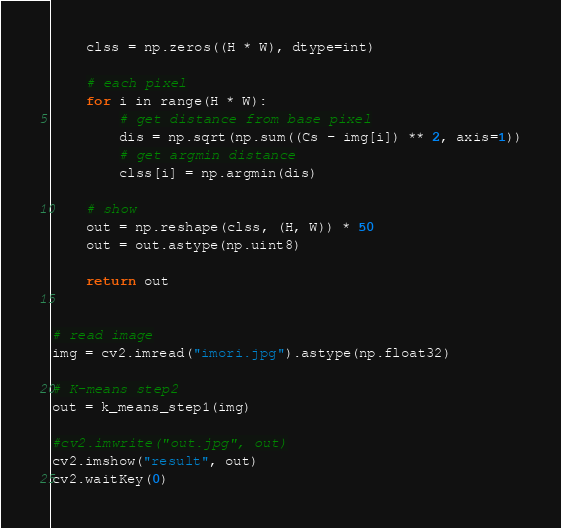<code> <loc_0><loc_0><loc_500><loc_500><_Python_>	clss = np.zeros((H * W), dtype=int)

	# each pixel
	for i in range(H * W):
		# get distance from base pixel
		dis = np.sqrt(np.sum((Cs - img[i]) ** 2, axis=1))
		# get argmin distance
		clss[i] = np.argmin(dis)

	# show
	out = np.reshape(clss, (H, W)) * 50
	out = out.astype(np.uint8)

	return out


# read image
img = cv2.imread("imori.jpg").astype(np.float32)

# K-means step2
out = k_means_step1(img)

#cv2.imwrite("out.jpg", out)
cv2.imshow("result", out)
cv2.waitKey(0)
</code> 